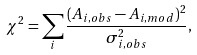Convert formula to latex. <formula><loc_0><loc_0><loc_500><loc_500>\chi ^ { 2 } = \sum _ { i } \frac { ( A _ { i , o b s } - A _ { i , m o d } ) ^ { 2 } } { \sigma ^ { 2 } _ { i , o b s } } ,</formula> 